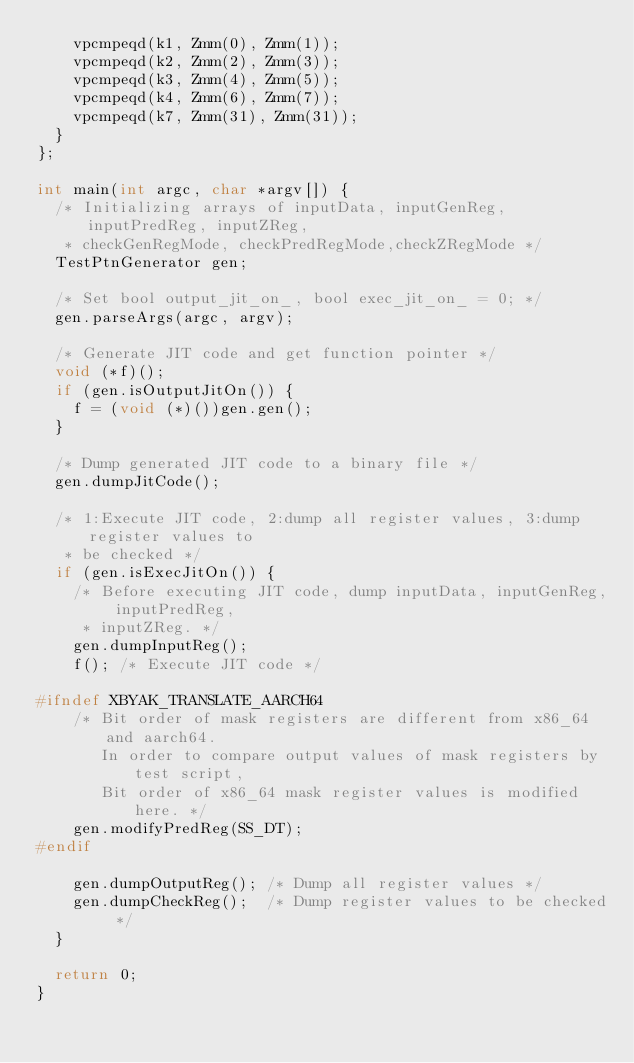<code> <loc_0><loc_0><loc_500><loc_500><_C++_>    vpcmpeqd(k1, Zmm(0), Zmm(1));
    vpcmpeqd(k2, Zmm(2), Zmm(3));
    vpcmpeqd(k3, Zmm(4), Zmm(5));
    vpcmpeqd(k4, Zmm(6), Zmm(7));
    vpcmpeqd(k7, Zmm(31), Zmm(31));
  }
};

int main(int argc, char *argv[]) {
  /* Initializing arrays of inputData, inputGenReg, inputPredReg, inputZReg,
   * checkGenRegMode, checkPredRegMode,checkZRegMode */
  TestPtnGenerator gen;

  /* Set bool output_jit_on_, bool exec_jit_on_ = 0; */
  gen.parseArgs(argc, argv);

  /* Generate JIT code and get function pointer */
  void (*f)();
  if (gen.isOutputJitOn()) {
    f = (void (*)())gen.gen();
  }

  /* Dump generated JIT code to a binary file */
  gen.dumpJitCode();

  /* 1:Execute JIT code, 2:dump all register values, 3:dump register values to
   * be checked */
  if (gen.isExecJitOn()) {
    /* Before executing JIT code, dump inputData, inputGenReg, inputPredReg,
     * inputZReg. */
    gen.dumpInputReg();
    f(); /* Execute JIT code */

#ifndef XBYAK_TRANSLATE_AARCH64
    /* Bit order of mask registers are different from x86_64 and aarch64.
       In order to compare output values of mask registers by test script,
       Bit order of x86_64 mask register values is modified here. */
    gen.modifyPredReg(SS_DT);
#endif

    gen.dumpOutputReg(); /* Dump all register values */
    gen.dumpCheckReg();  /* Dump register values to be checked */
  }

  return 0;
}
</code> 